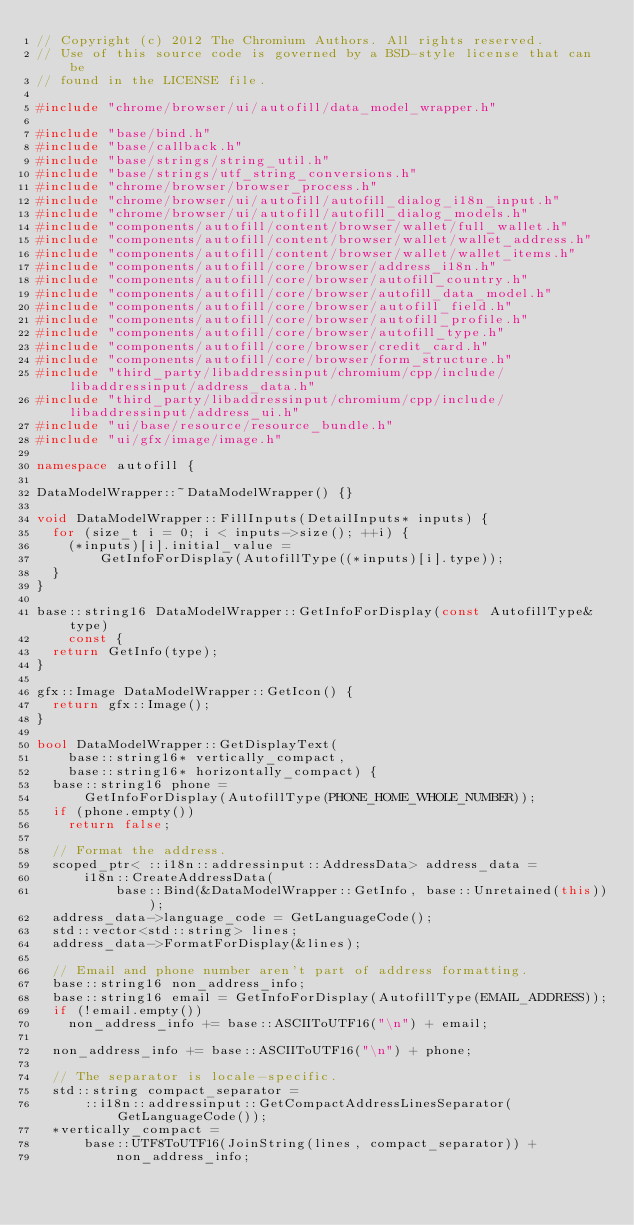<code> <loc_0><loc_0><loc_500><loc_500><_C++_>// Copyright (c) 2012 The Chromium Authors. All rights reserved.
// Use of this source code is governed by a BSD-style license that can be
// found in the LICENSE file.

#include "chrome/browser/ui/autofill/data_model_wrapper.h"

#include "base/bind.h"
#include "base/callback.h"
#include "base/strings/string_util.h"
#include "base/strings/utf_string_conversions.h"
#include "chrome/browser/browser_process.h"
#include "chrome/browser/ui/autofill/autofill_dialog_i18n_input.h"
#include "chrome/browser/ui/autofill/autofill_dialog_models.h"
#include "components/autofill/content/browser/wallet/full_wallet.h"
#include "components/autofill/content/browser/wallet/wallet_address.h"
#include "components/autofill/content/browser/wallet/wallet_items.h"
#include "components/autofill/core/browser/address_i18n.h"
#include "components/autofill/core/browser/autofill_country.h"
#include "components/autofill/core/browser/autofill_data_model.h"
#include "components/autofill/core/browser/autofill_field.h"
#include "components/autofill/core/browser/autofill_profile.h"
#include "components/autofill/core/browser/autofill_type.h"
#include "components/autofill/core/browser/credit_card.h"
#include "components/autofill/core/browser/form_structure.h"
#include "third_party/libaddressinput/chromium/cpp/include/libaddressinput/address_data.h"
#include "third_party/libaddressinput/chromium/cpp/include/libaddressinput/address_ui.h"
#include "ui/base/resource/resource_bundle.h"
#include "ui/gfx/image/image.h"

namespace autofill {

DataModelWrapper::~DataModelWrapper() {}

void DataModelWrapper::FillInputs(DetailInputs* inputs) {
  for (size_t i = 0; i < inputs->size(); ++i) {
    (*inputs)[i].initial_value =
        GetInfoForDisplay(AutofillType((*inputs)[i].type));
  }
}

base::string16 DataModelWrapper::GetInfoForDisplay(const AutofillType& type)
    const {
  return GetInfo(type);
}

gfx::Image DataModelWrapper::GetIcon() {
  return gfx::Image();
}

bool DataModelWrapper::GetDisplayText(
    base::string16* vertically_compact,
    base::string16* horizontally_compact) {
  base::string16 phone =
      GetInfoForDisplay(AutofillType(PHONE_HOME_WHOLE_NUMBER));
  if (phone.empty())
    return false;

  // Format the address.
  scoped_ptr< ::i18n::addressinput::AddressData> address_data =
      i18n::CreateAddressData(
          base::Bind(&DataModelWrapper::GetInfo, base::Unretained(this)));
  address_data->language_code = GetLanguageCode();
  std::vector<std::string> lines;
  address_data->FormatForDisplay(&lines);

  // Email and phone number aren't part of address formatting.
  base::string16 non_address_info;
  base::string16 email = GetInfoForDisplay(AutofillType(EMAIL_ADDRESS));
  if (!email.empty())
    non_address_info += base::ASCIIToUTF16("\n") + email;

  non_address_info += base::ASCIIToUTF16("\n") + phone;

  // The separator is locale-specific.
  std::string compact_separator =
      ::i18n::addressinput::GetCompactAddressLinesSeparator(GetLanguageCode());
  *vertically_compact =
      base::UTF8ToUTF16(JoinString(lines, compact_separator)) +
          non_address_info;</code> 